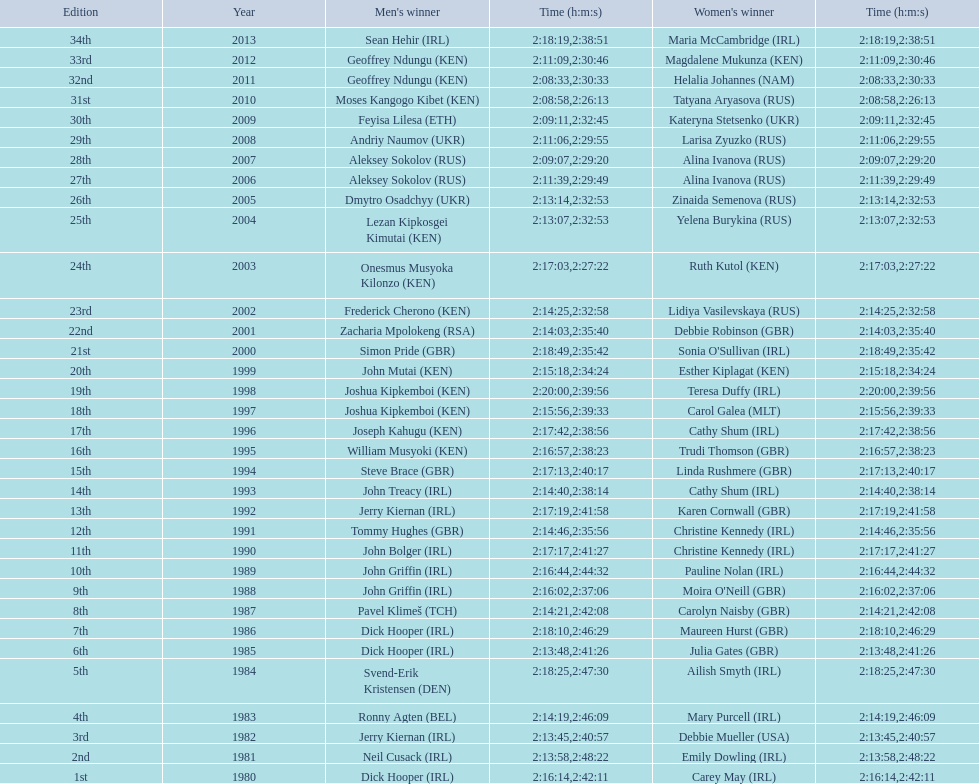Which nation is represented for both males and females at the peak of the list? Ireland. 